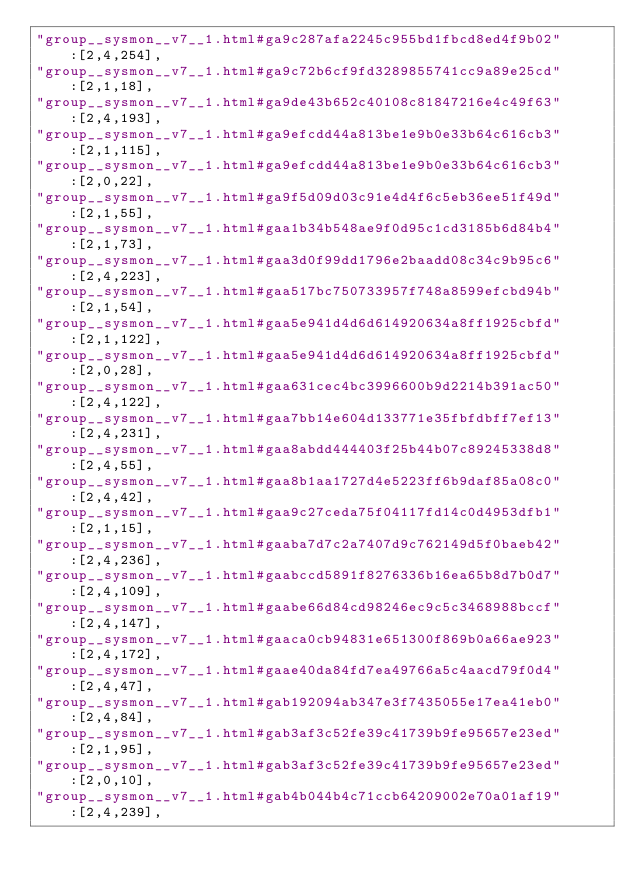Convert code to text. <code><loc_0><loc_0><loc_500><loc_500><_JavaScript_>"group__sysmon__v7__1.html#ga9c287afa2245c955bd1fbcd8ed4f9b02":[2,4,254],
"group__sysmon__v7__1.html#ga9c72b6cf9fd3289855741cc9a89e25cd":[2,1,18],
"group__sysmon__v7__1.html#ga9de43b652c40108c81847216e4c49f63":[2,4,193],
"group__sysmon__v7__1.html#ga9efcdd44a813be1e9b0e33b64c616cb3":[2,1,115],
"group__sysmon__v7__1.html#ga9efcdd44a813be1e9b0e33b64c616cb3":[2,0,22],
"group__sysmon__v7__1.html#ga9f5d09d03c91e4d4f6c5eb36ee51f49d":[2,1,55],
"group__sysmon__v7__1.html#gaa1b34b548ae9f0d95c1cd3185b6d84b4":[2,1,73],
"group__sysmon__v7__1.html#gaa3d0f99dd1796e2baadd08c34c9b95c6":[2,4,223],
"group__sysmon__v7__1.html#gaa517bc750733957f748a8599efcbd94b":[2,1,54],
"group__sysmon__v7__1.html#gaa5e941d4d6d614920634a8ff1925cbfd":[2,1,122],
"group__sysmon__v7__1.html#gaa5e941d4d6d614920634a8ff1925cbfd":[2,0,28],
"group__sysmon__v7__1.html#gaa631cec4bc3996600b9d2214b391ac50":[2,4,122],
"group__sysmon__v7__1.html#gaa7bb14e604d133771e35fbfdbff7ef13":[2,4,231],
"group__sysmon__v7__1.html#gaa8abdd444403f25b44b07c89245338d8":[2,4,55],
"group__sysmon__v7__1.html#gaa8b1aa1727d4e5223ff6b9daf85a08c0":[2,4,42],
"group__sysmon__v7__1.html#gaa9c27ceda75f04117fd14c0d4953dfb1":[2,1,15],
"group__sysmon__v7__1.html#gaaba7d7c2a7407d9c762149d5f0baeb42":[2,4,236],
"group__sysmon__v7__1.html#gaabccd5891f8276336b16ea65b8d7b0d7":[2,4,109],
"group__sysmon__v7__1.html#gaabe66d84cd98246ec9c5c3468988bccf":[2,4,147],
"group__sysmon__v7__1.html#gaaca0cb94831e651300f869b0a66ae923":[2,4,172],
"group__sysmon__v7__1.html#gaae40da84fd7ea49766a5c4aacd79f0d4":[2,4,47],
"group__sysmon__v7__1.html#gab192094ab347e3f7435055e17ea41eb0":[2,4,84],
"group__sysmon__v7__1.html#gab3af3c52fe39c41739b9fe95657e23ed":[2,1,95],
"group__sysmon__v7__1.html#gab3af3c52fe39c41739b9fe95657e23ed":[2,0,10],
"group__sysmon__v7__1.html#gab4b044b4c71ccb64209002e70a01af19":[2,4,239],</code> 